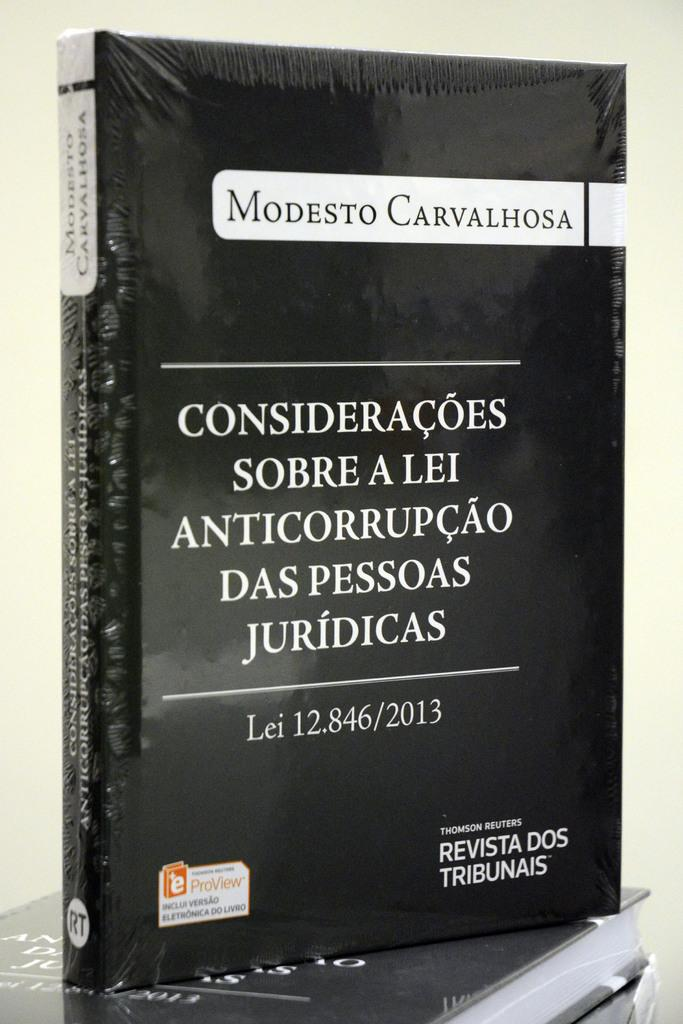<image>
Give a short and clear explanation of the subsequent image. Modesto Carvalhosa is a black bound book that is written entirely in spanish 